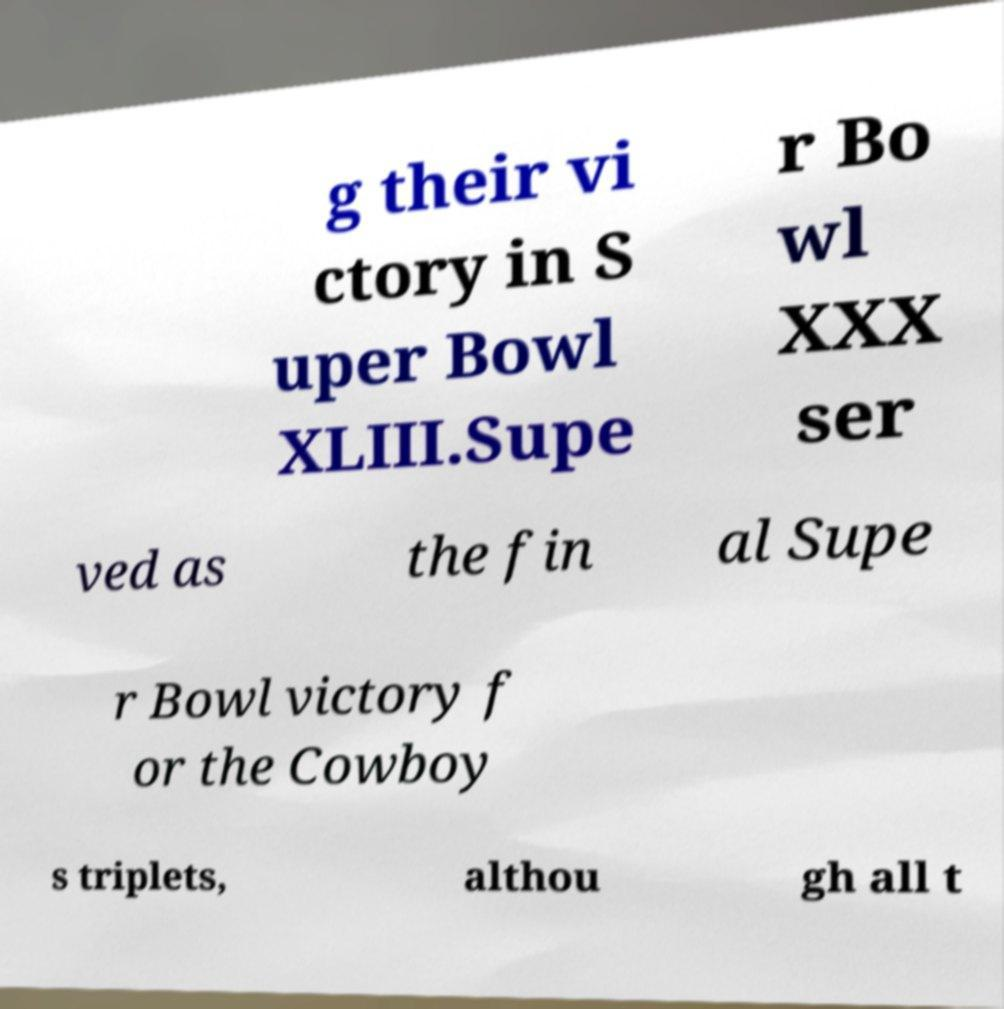What messages or text are displayed in this image? I need them in a readable, typed format. g their vi ctory in S uper Bowl XLIII.Supe r Bo wl XXX ser ved as the fin al Supe r Bowl victory f or the Cowboy s triplets, althou gh all t 